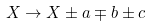Convert formula to latex. <formula><loc_0><loc_0><loc_500><loc_500>X \to X \pm a \mp b \pm c</formula> 